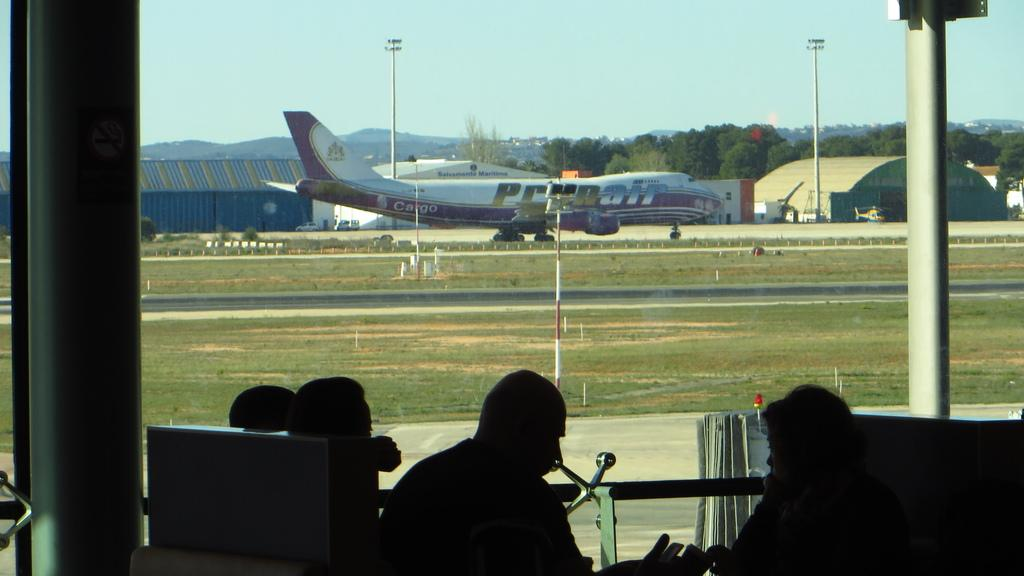<image>
Share a concise interpretation of the image provided. A plane has the word cargo painted on its side. 